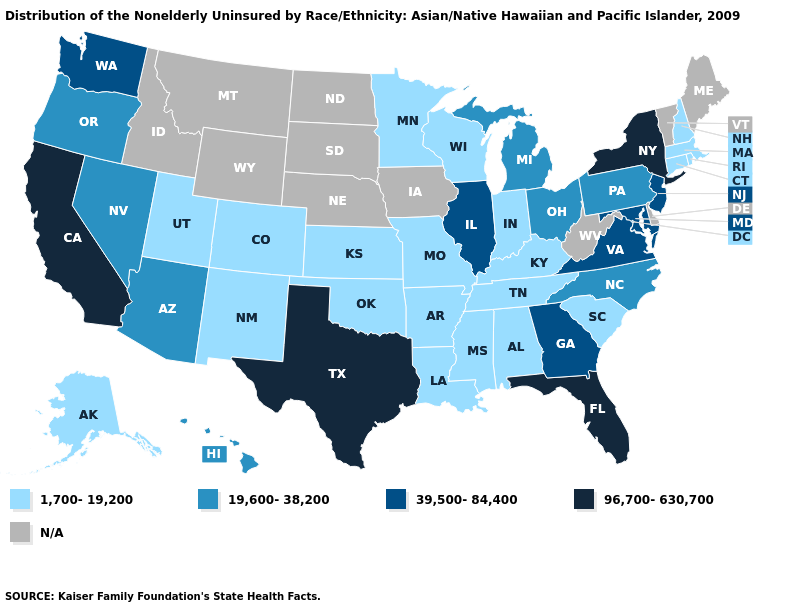Does Michigan have the lowest value in the USA?
Keep it brief. No. What is the lowest value in the Northeast?
Concise answer only. 1,700-19,200. What is the value of New Hampshire?
Short answer required. 1,700-19,200. Which states have the highest value in the USA?
Be succinct. California, Florida, New York, Texas. What is the highest value in the USA?
Concise answer only. 96,700-630,700. What is the value of Montana?
Answer briefly. N/A. Among the states that border Colorado , does Arizona have the lowest value?
Quick response, please. No. Among the states that border South Carolina , which have the highest value?
Write a very short answer. Georgia. What is the value of New Mexico?
Concise answer only. 1,700-19,200. Among the states that border Pennsylvania , which have the lowest value?
Concise answer only. Ohio. What is the value of Florida?
Quick response, please. 96,700-630,700. Name the states that have a value in the range 1,700-19,200?
Answer briefly. Alabama, Alaska, Arkansas, Colorado, Connecticut, Indiana, Kansas, Kentucky, Louisiana, Massachusetts, Minnesota, Mississippi, Missouri, New Hampshire, New Mexico, Oklahoma, Rhode Island, South Carolina, Tennessee, Utah, Wisconsin. What is the value of New Hampshire?
Be succinct. 1,700-19,200. Does the map have missing data?
Answer briefly. Yes. 